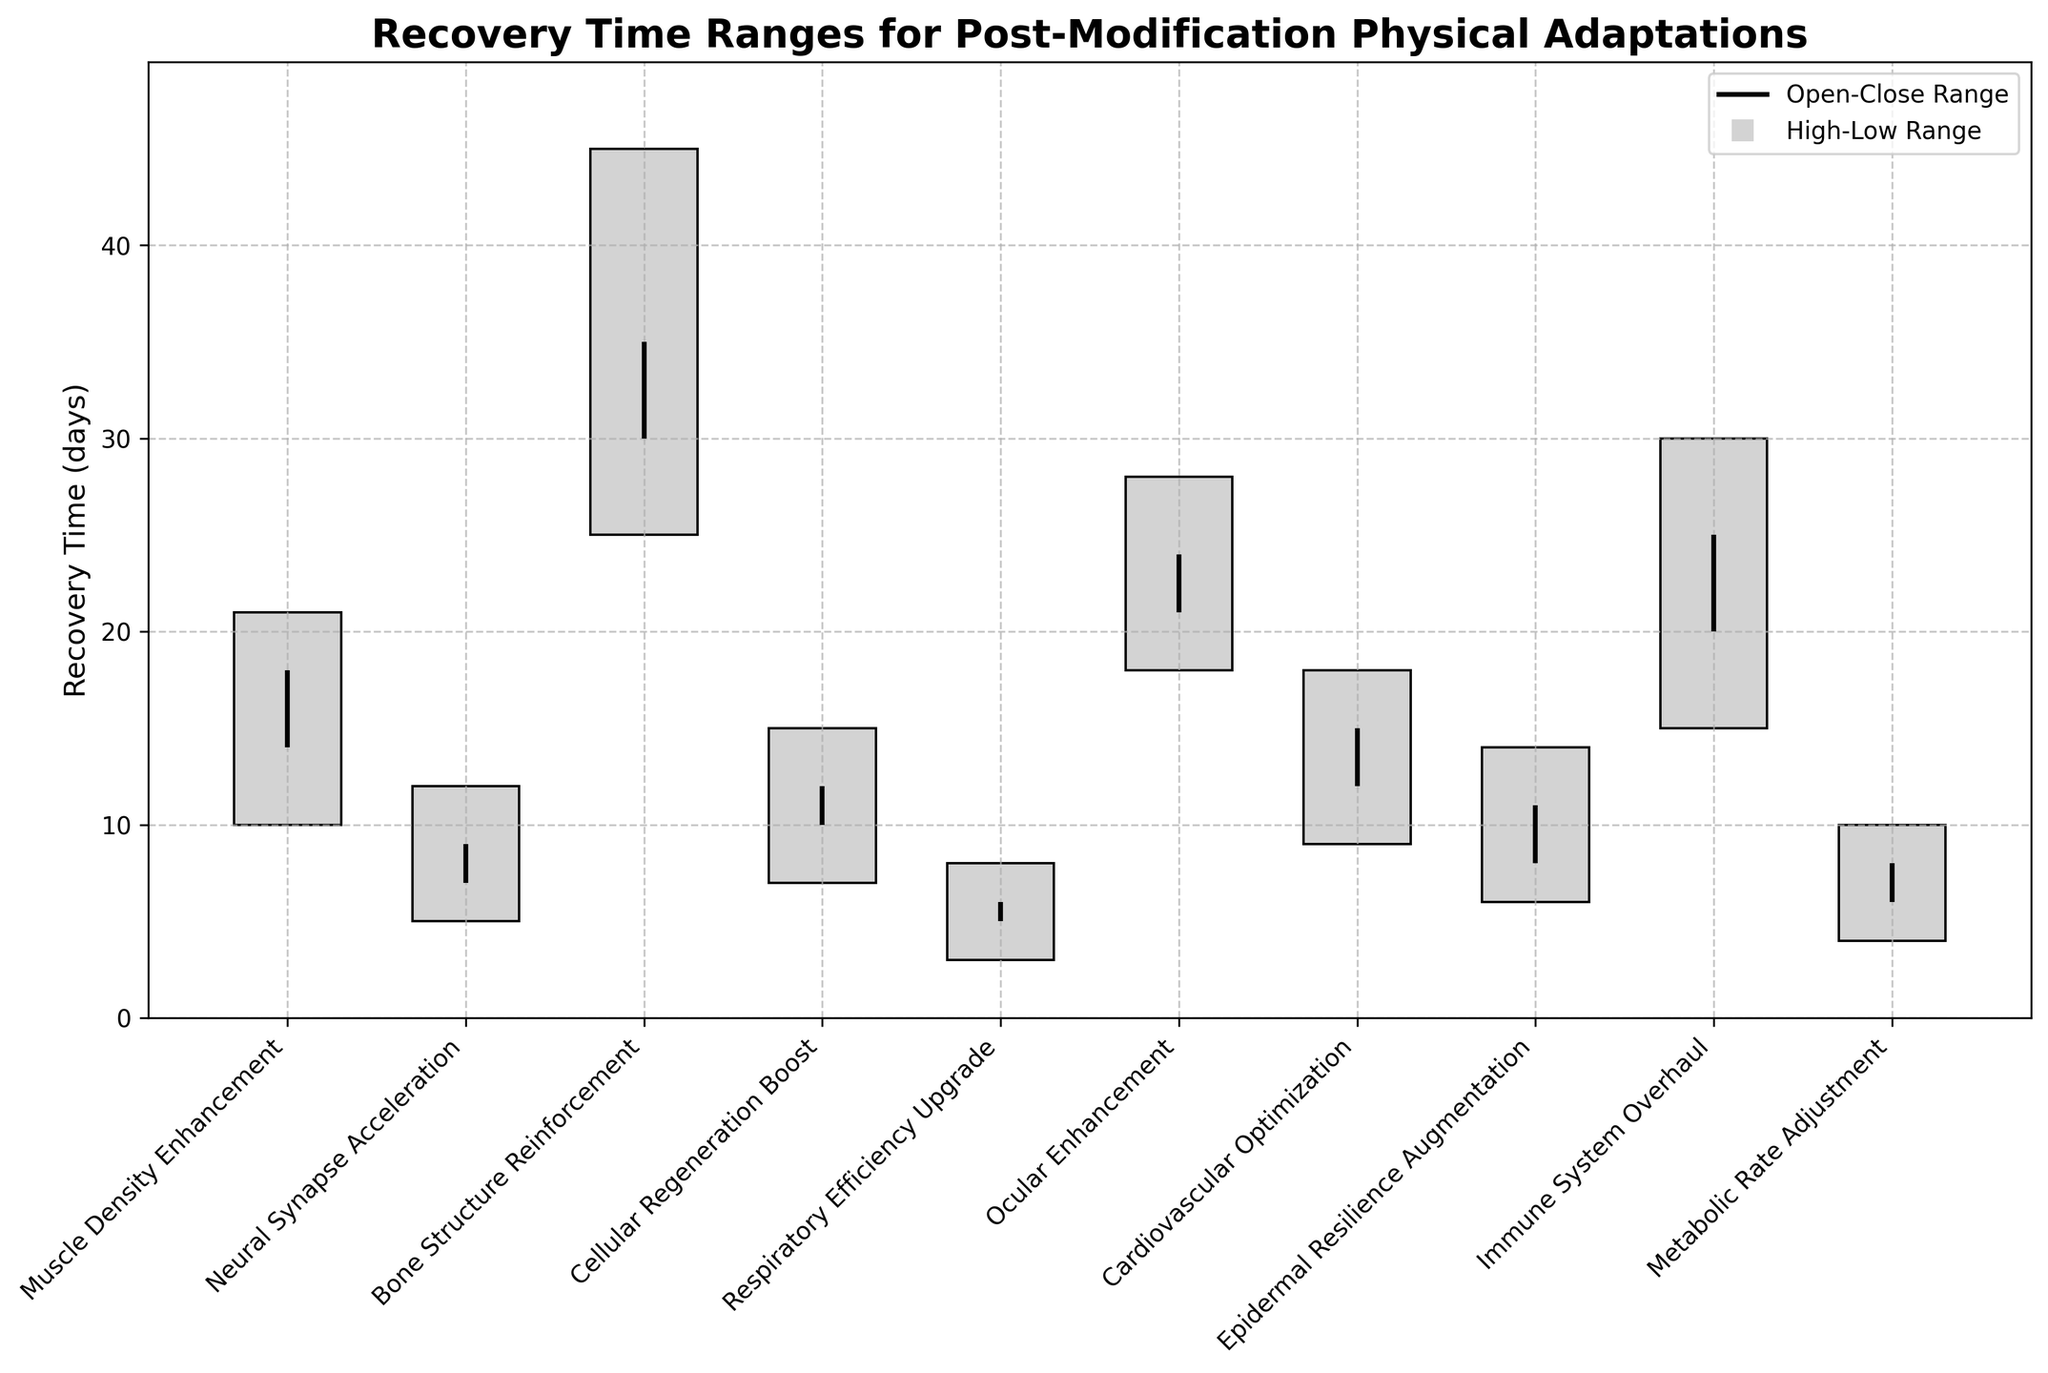What is the title of the figure? The title of the figure is usually displayed at the top in a bold font. In this figure, the title is clearly shown.
Answer: Recovery Time Ranges for Post-Modification Physical Adaptations How many modifications are compared in the figure? Count the number of different modification names on the x-axis.
Answer: 10 Which modification has the highest recovery time range? Look for the bar with the highest range (difference between high and low) on the y-axis. In this case, it's clearly visible.
Answer: Bone Structure Reinforcement What is the recovery time range for "Neural Synapse Acceleration"? Refer to the corresponding bar and note the low and high values. The range is high - low.
Answer: 12 - 5 = 7 days Which modifications have a recovery time range of more than 20 days? Identify the bars where the difference between high and low values is greater than 20. Only "Bone Structure Reinforcement" and "Immune System Overhaul" meet this criterion.
Answer: Bone Structure Reinforcement and Immune System Overhaul What is the average open time across all modifications? Sum all the 'Open' values and divide by the number of modifications. (14 + 7 + 30 + 10 + 5 + 21 + 12 + 8 + 20 + 6) / 10.
Answer: 13.3 days How does "Epidermal Resilience Augmentation" compare to "Ocular Enhancement" in terms of the high value? Look at the high values for both modifications on the y-axis and compare them.
Answer: Ocular Enhancement (28) is higher than Epidermal Resilience Augmentation (14) What is the median close time value for all modifications? Arrange the close values in ascending order and find the middle value. Since there are 10 values, the median is the average of the 5th and 6th values.
Answer: (12 + 15) / 2 = 13.5 days 